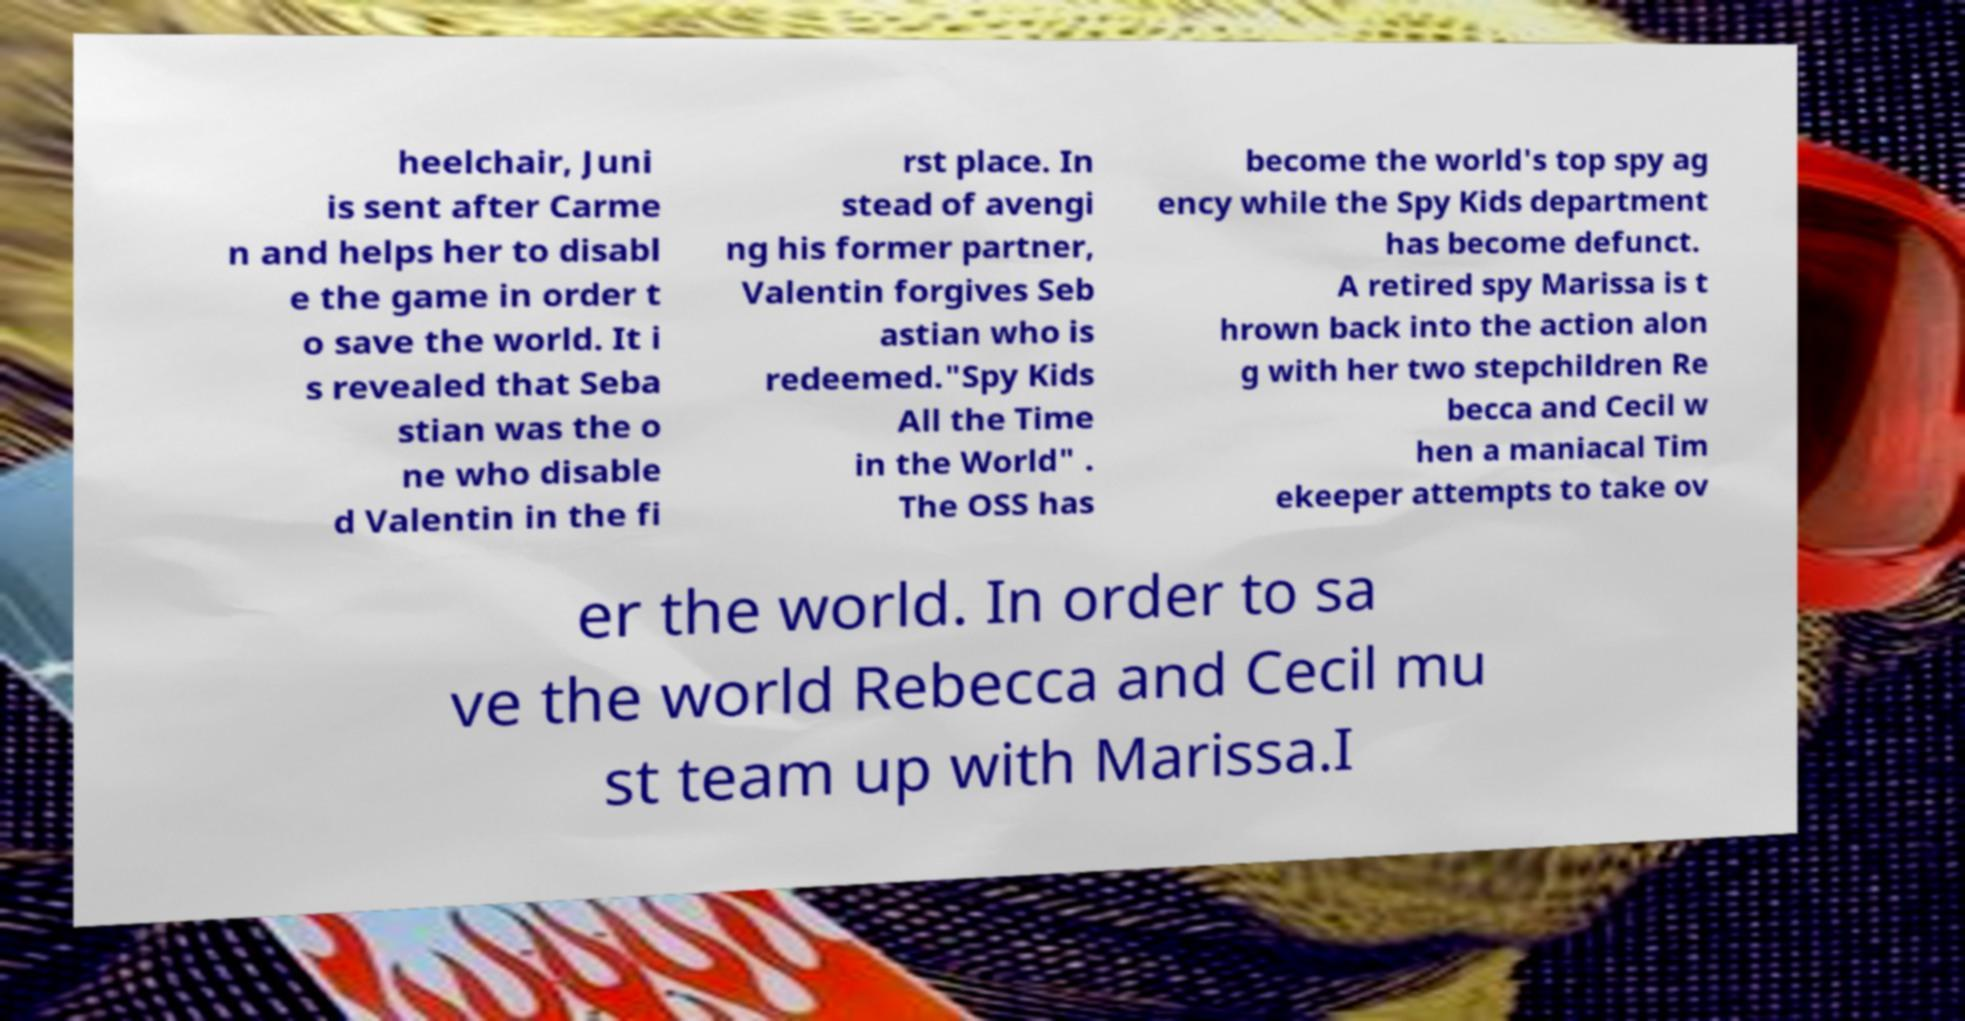Could you extract and type out the text from this image? heelchair, Juni is sent after Carme n and helps her to disabl e the game in order t o save the world. It i s revealed that Seba stian was the o ne who disable d Valentin in the fi rst place. In stead of avengi ng his former partner, Valentin forgives Seb astian who is redeemed."Spy Kids All the Time in the World" . The OSS has become the world's top spy ag ency while the Spy Kids department has become defunct. A retired spy Marissa is t hrown back into the action alon g with her two stepchildren Re becca and Cecil w hen a maniacal Tim ekeeper attempts to take ov er the world. In order to sa ve the world Rebecca and Cecil mu st team up with Marissa.I 